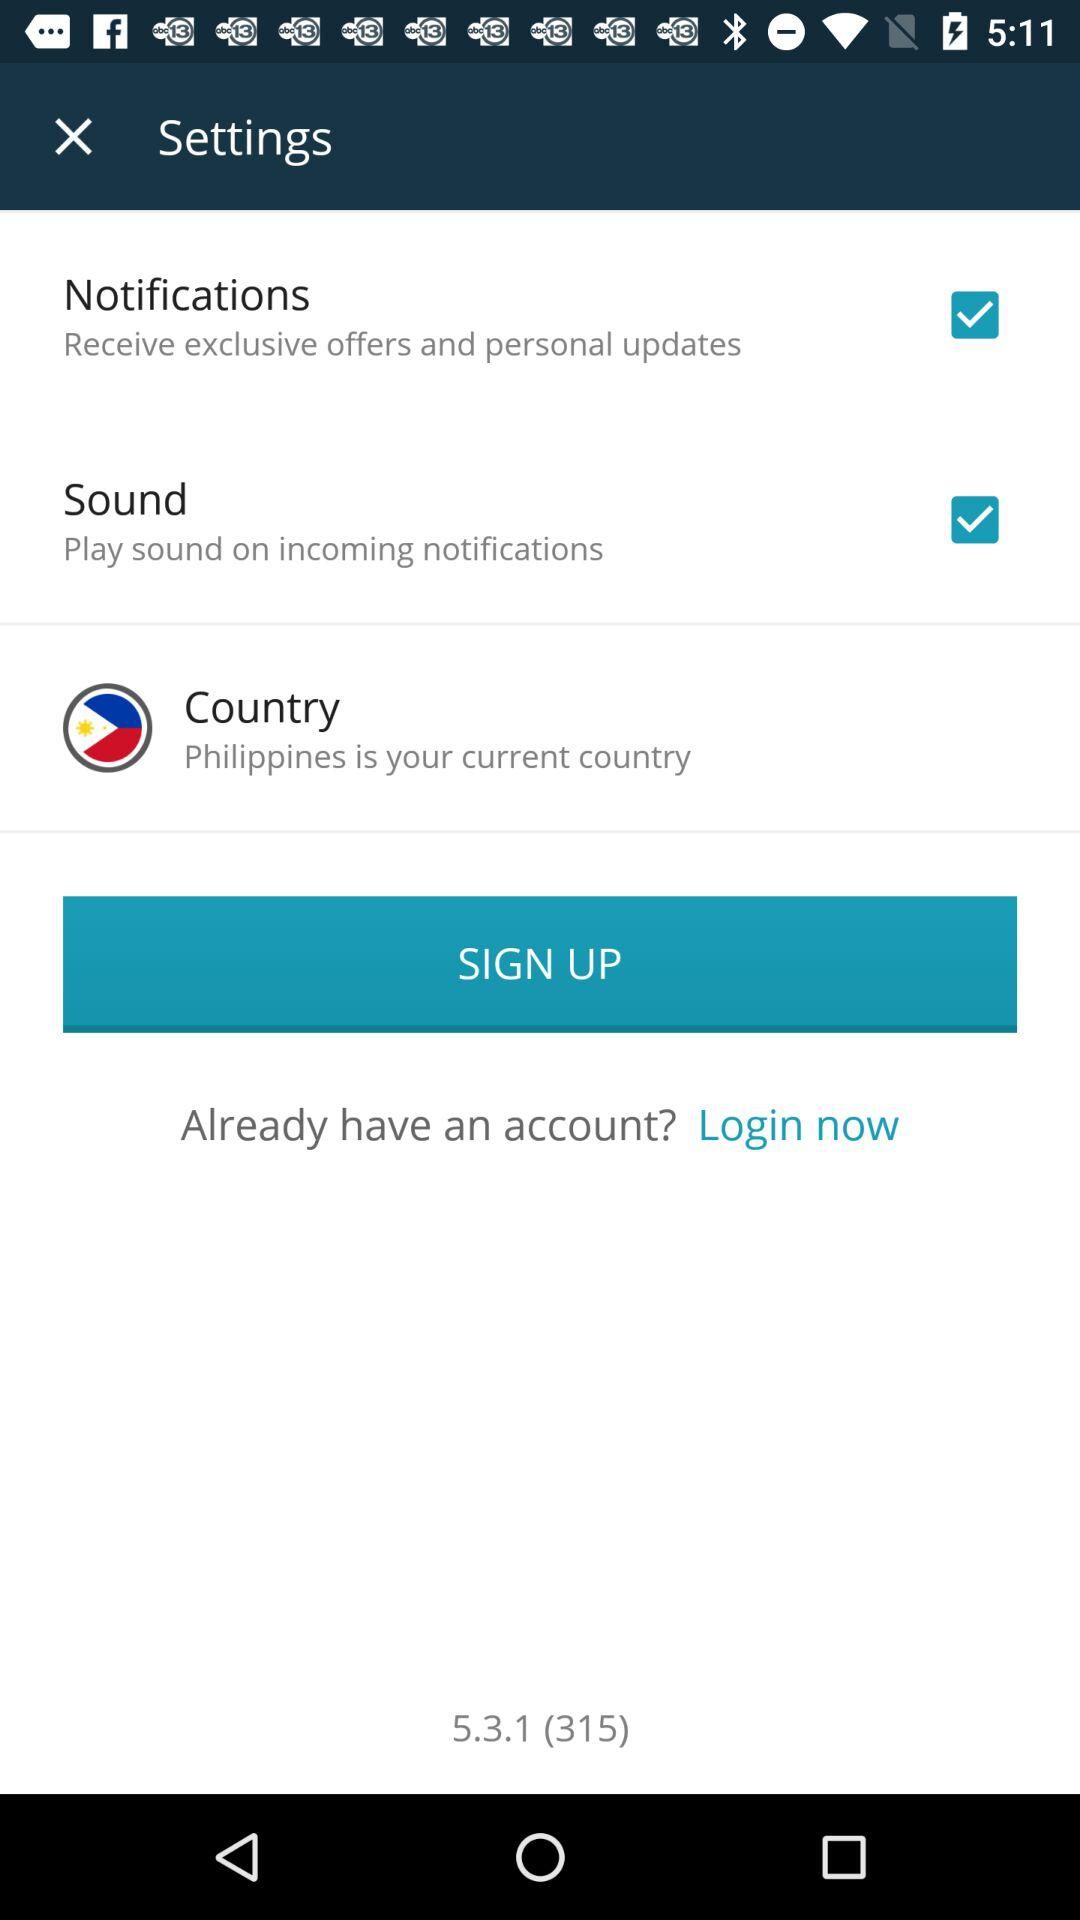Which option is marked as checked? The options that are marked as checked are "Notifications" and "Sound". 